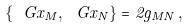Convert formula to latex. <formula><loc_0><loc_0><loc_500><loc_500>\left \{ \ G x _ { M } , \ G x _ { N } \right \} = 2 g _ { M N } \, ,</formula> 